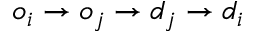<formula> <loc_0><loc_0><loc_500><loc_500>o _ { i } \rightarrow o _ { j } \rightarrow d _ { j } \rightarrow d _ { i }</formula> 